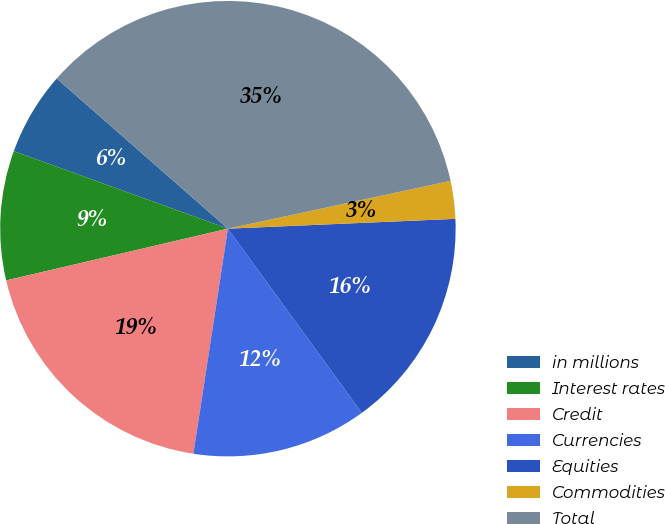<chart> <loc_0><loc_0><loc_500><loc_500><pie_chart><fcel>in millions<fcel>Interest rates<fcel>Credit<fcel>Currencies<fcel>Equities<fcel>Commodities<fcel>Total<nl><fcel>5.93%<fcel>9.18%<fcel>18.93%<fcel>12.43%<fcel>15.68%<fcel>2.68%<fcel>35.18%<nl></chart> 